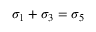<formula> <loc_0><loc_0><loc_500><loc_500>\sigma _ { 1 } + \sigma _ { 3 } = \sigma _ { 5 }</formula> 